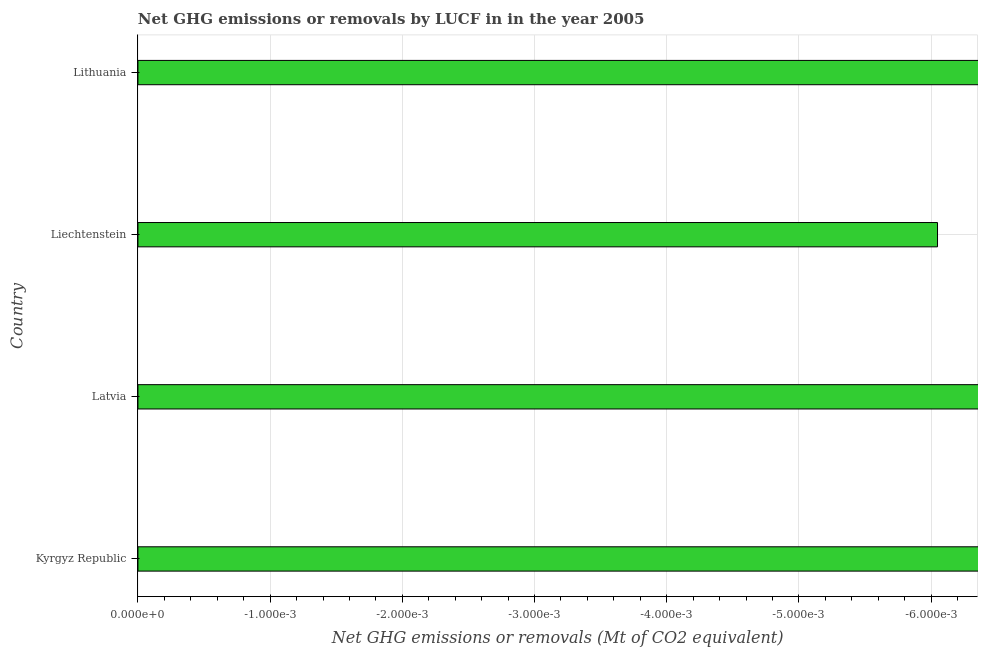Does the graph contain any zero values?
Offer a very short reply. Yes. What is the title of the graph?
Ensure brevity in your answer.  Net GHG emissions or removals by LUCF in in the year 2005. What is the label or title of the X-axis?
Your answer should be compact. Net GHG emissions or removals (Mt of CO2 equivalent). What is the ghg net emissions or removals in Latvia?
Your answer should be compact. 0. Across all countries, what is the minimum ghg net emissions or removals?
Give a very brief answer. 0. What is the average ghg net emissions or removals per country?
Make the answer very short. 0. In how many countries, is the ghg net emissions or removals greater than the average ghg net emissions or removals taken over all countries?
Keep it short and to the point. 0. Are all the bars in the graph horizontal?
Provide a short and direct response. Yes. How many countries are there in the graph?
Make the answer very short. 4. What is the difference between two consecutive major ticks on the X-axis?
Your answer should be compact. 0. 